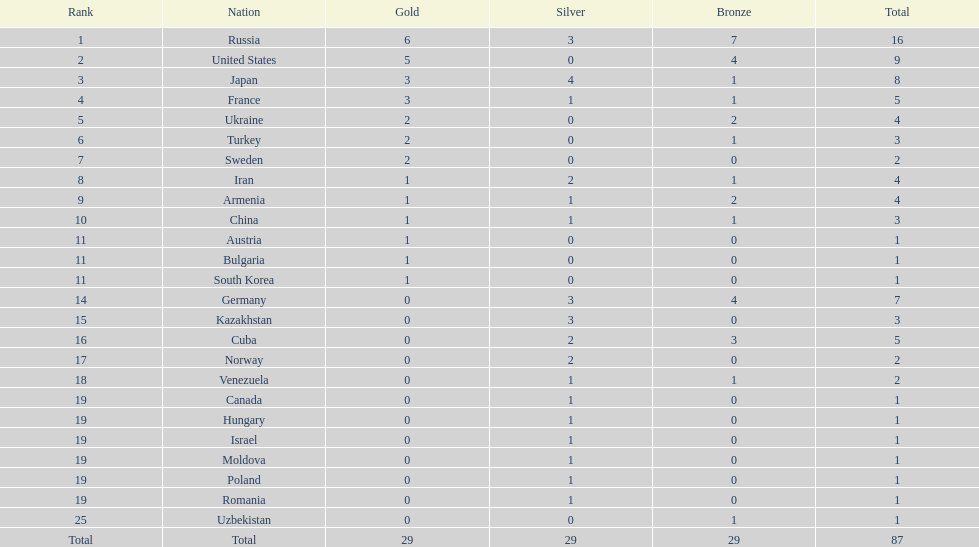What is the combined sum of gold medals that japan and france achieved? 6. 